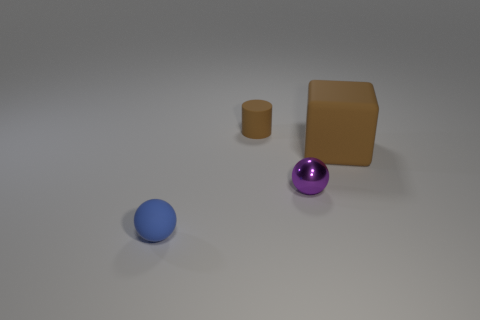Is there anything else that is the same size as the brown matte cube?
Give a very brief answer. No. What is the material of the small cylinder?
Provide a succinct answer. Rubber. How many things are either small things behind the purple metallic thing or objects that are in front of the small brown rubber thing?
Give a very brief answer. 4. What number of other objects are the same color as the shiny object?
Give a very brief answer. 0. Do the small brown object and the small matte object that is in front of the brown matte cylinder have the same shape?
Your response must be concise. No. Are there fewer tiny purple metal things to the right of the purple metal sphere than brown matte blocks that are behind the rubber cylinder?
Make the answer very short. No. What material is the other thing that is the same shape as the purple thing?
Offer a very short reply. Rubber. Are there any other things that are made of the same material as the purple thing?
Your answer should be compact. No. Does the rubber cube have the same color as the cylinder?
Offer a terse response. Yes. What is the shape of the brown thing that is made of the same material as the tiny cylinder?
Provide a short and direct response. Cube. 